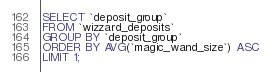<code> <loc_0><loc_0><loc_500><loc_500><_SQL_>SELECT `deposit_group`
FROM `wizzard_deposits`
GROUP BY `deposit_group`
ORDER BY AVG(`magic_wand_size`) ASC
LIMIT 1;</code> 